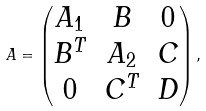Convert formula to latex. <formula><loc_0><loc_0><loc_500><loc_500>A = \begin{pmatrix} A _ { 1 } & B & 0 \\ B ^ { T } & A _ { 2 } & C \\ 0 & C ^ { T } & D \end{pmatrix} ,</formula> 